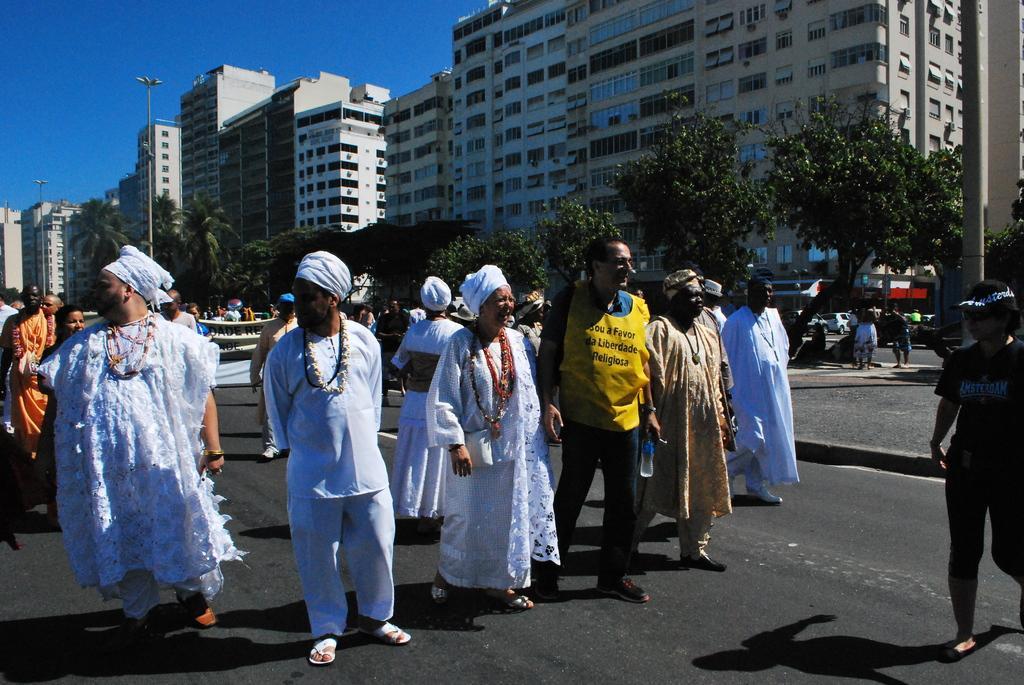Can you describe this image briefly? In this image we can see some persons on the road. We can also see a man holding the water bottle and standing on the road. In the background there are many trees, buildings and also light poles. Sky is also visible. 